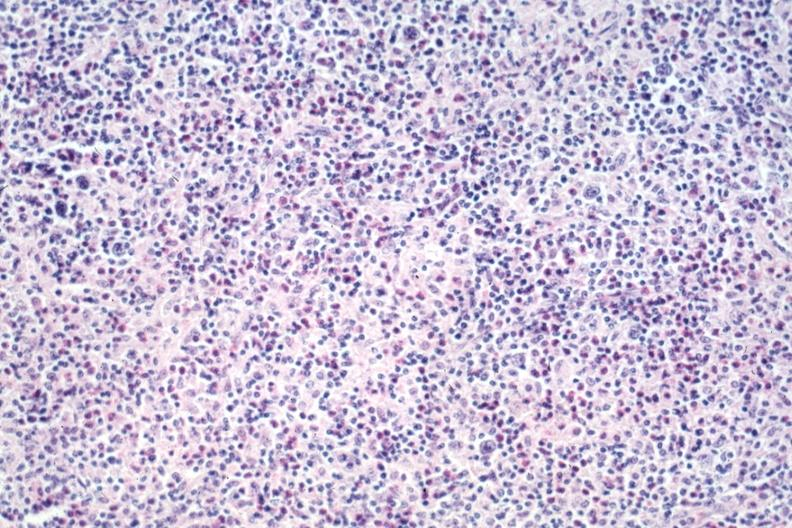s hodgkins disease present?
Answer the question using a single word or phrase. Yes 